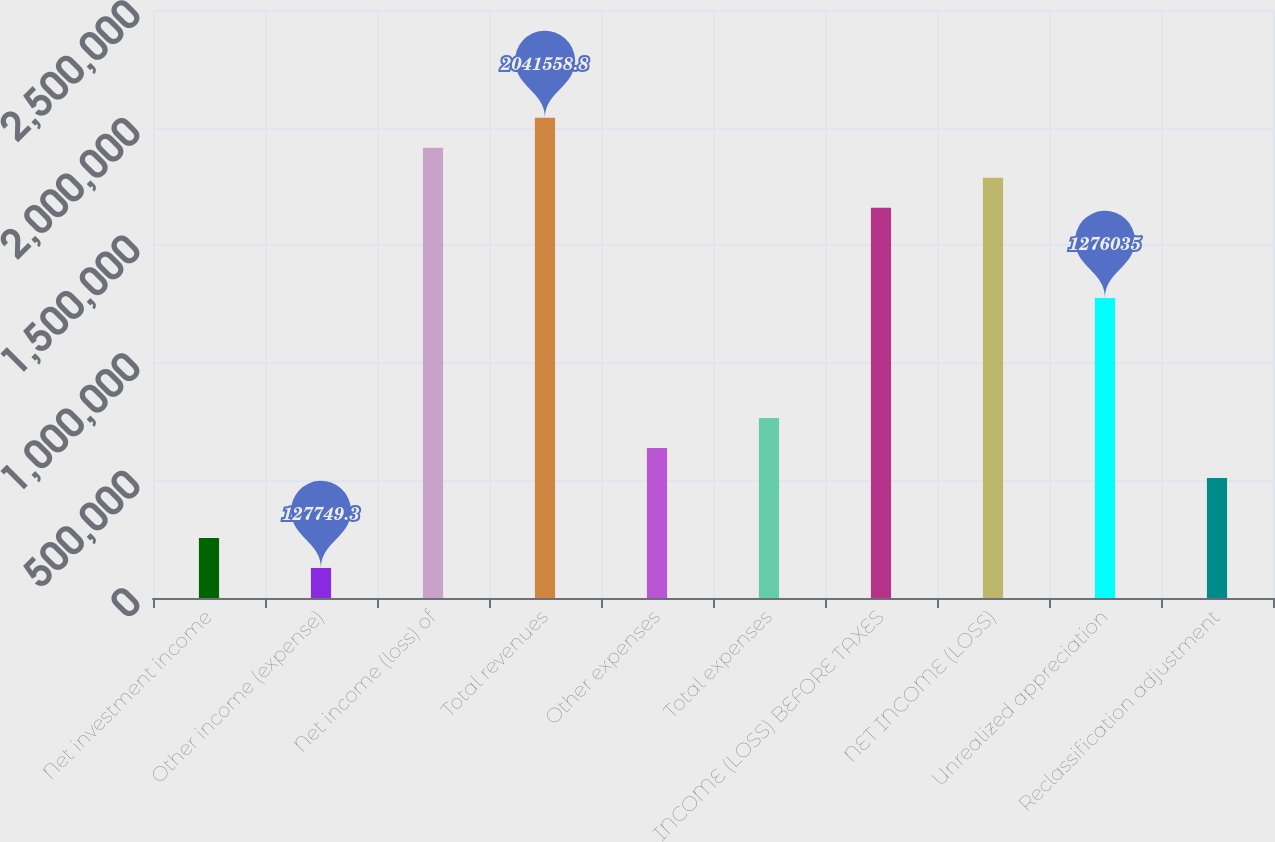Convert chart. <chart><loc_0><loc_0><loc_500><loc_500><bar_chart><fcel>Net investment income<fcel>Other income (expense)<fcel>Net income (loss) of<fcel>Total revenues<fcel>Other expenses<fcel>Total expenses<fcel>INCOME (LOSS) BEFORE TAXES<fcel>NET INCOME (LOSS)<fcel>Unrealized appreciation<fcel>Reclassification adjustment<nl><fcel>255337<fcel>127749<fcel>1.91397e+06<fcel>2.04156e+06<fcel>638098<fcel>765686<fcel>1.6588e+06<fcel>1.78638e+06<fcel>1.27604e+06<fcel>510511<nl></chart> 